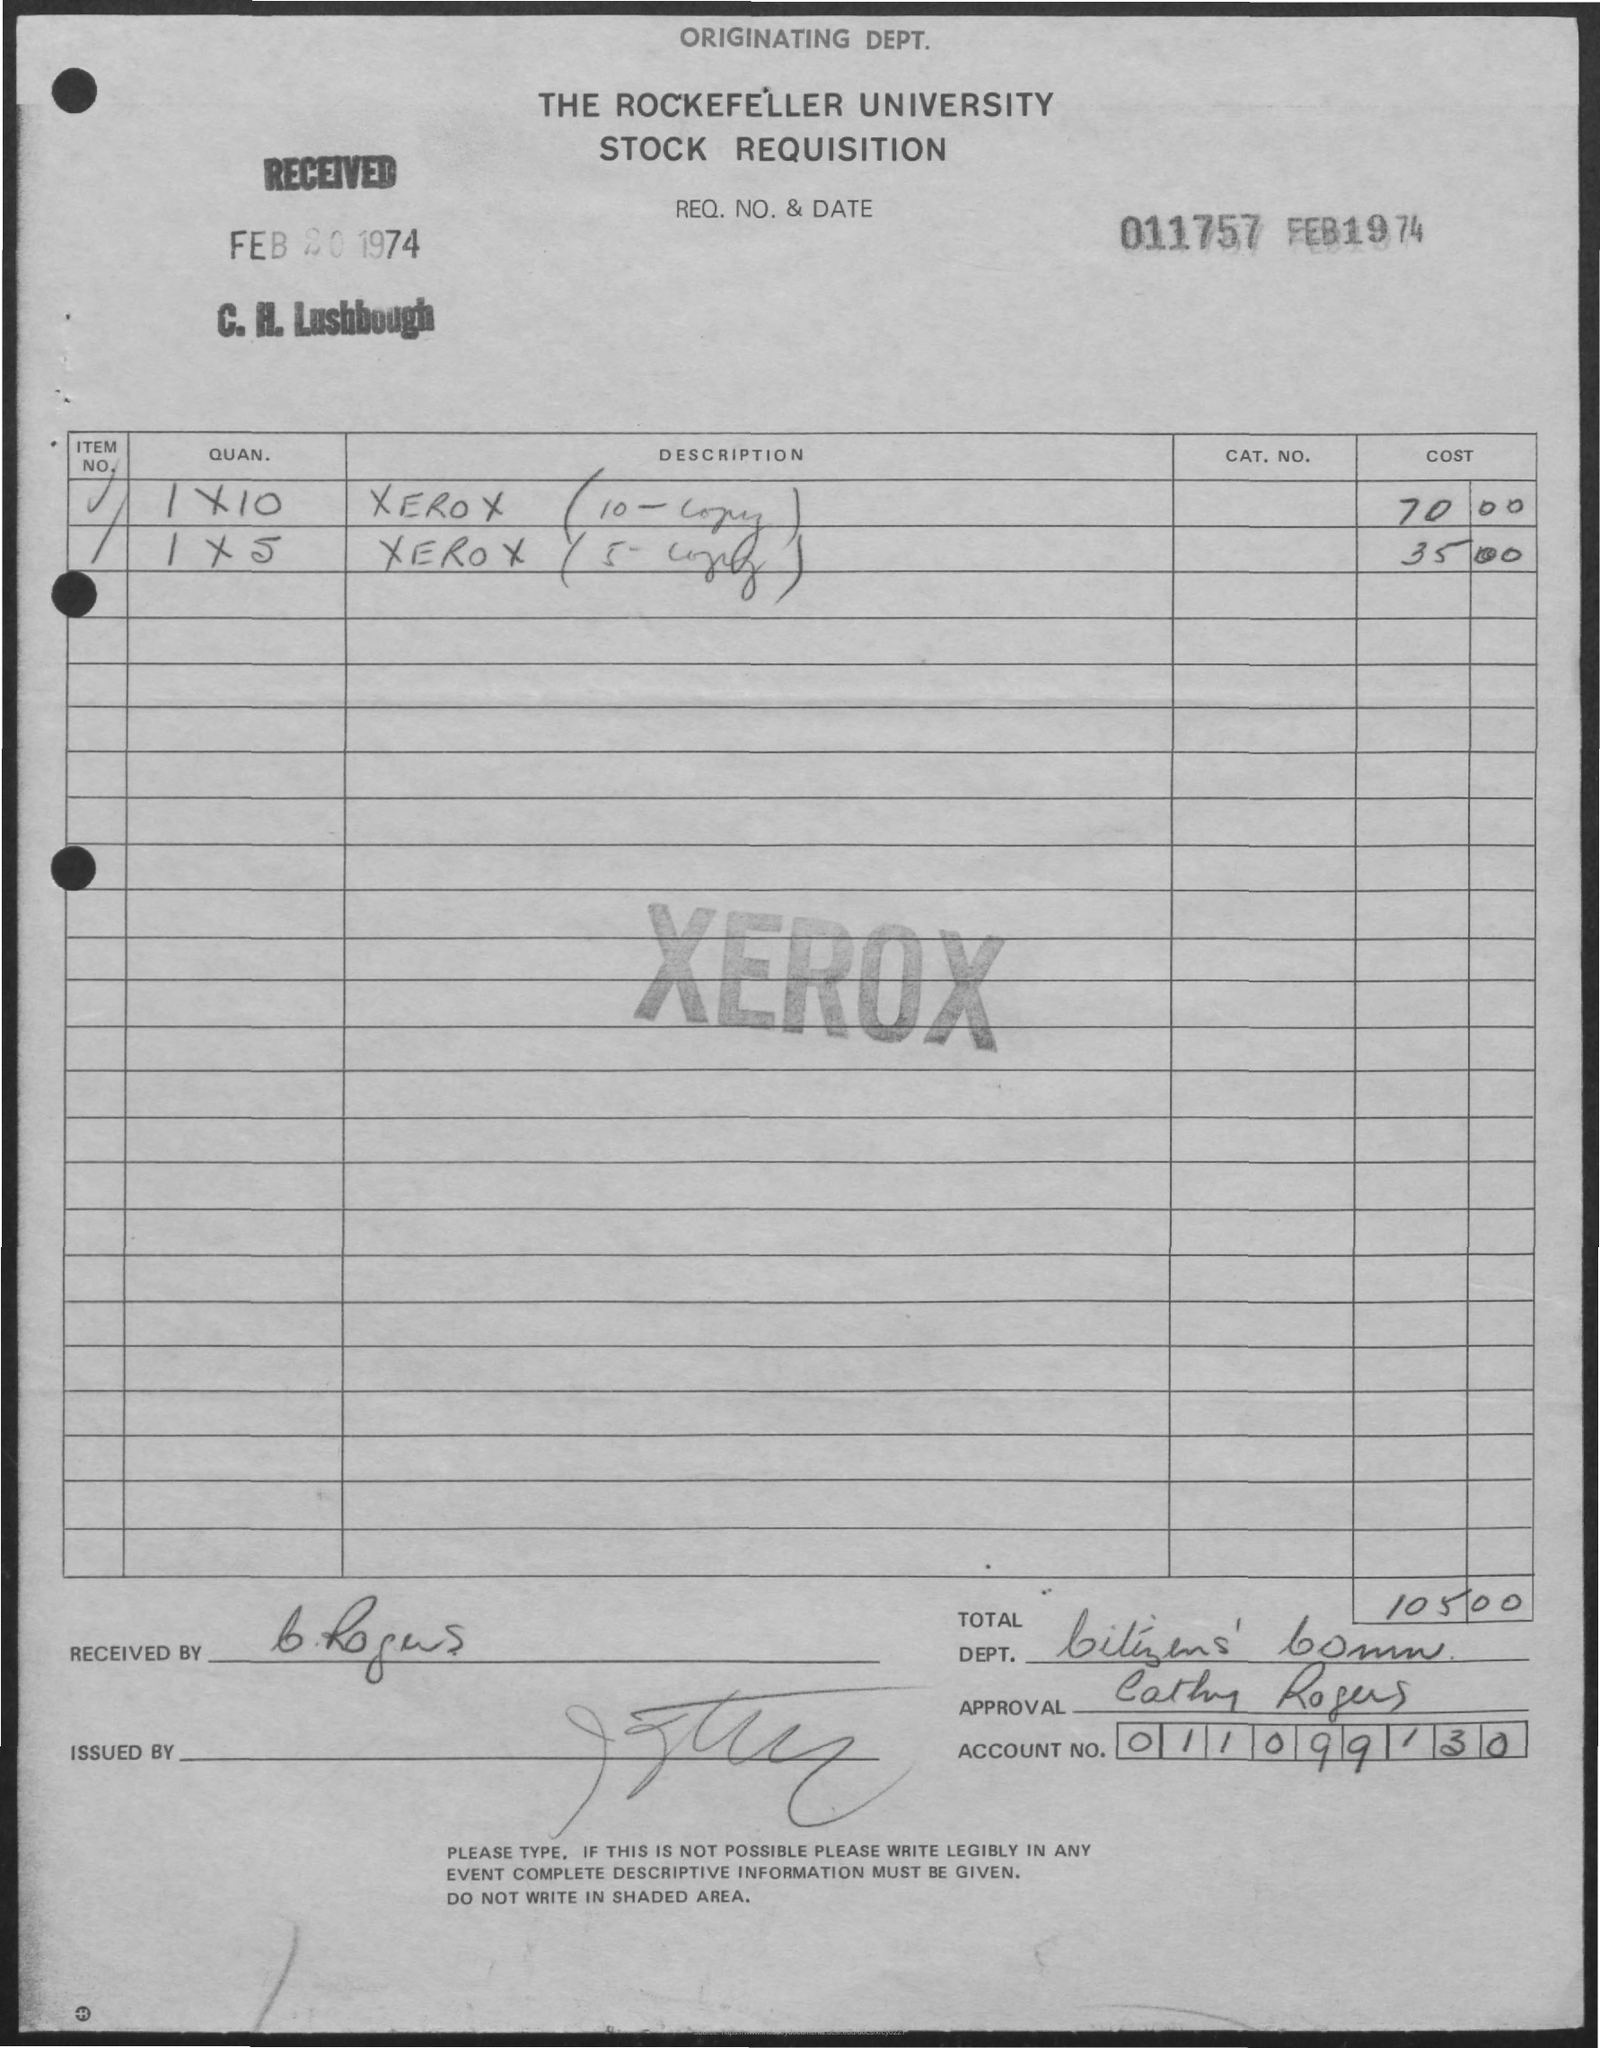List a handful of essential elements in this visual. The name "CATHY ROGERS" was mentioned in the approval. On February 20, 1974, the date of receipt was recorded. The cost of a 10-copy Xerox is $70.00. The cost of Xeroxing 5 copies is 35.00. February 1974 is mentioned. 